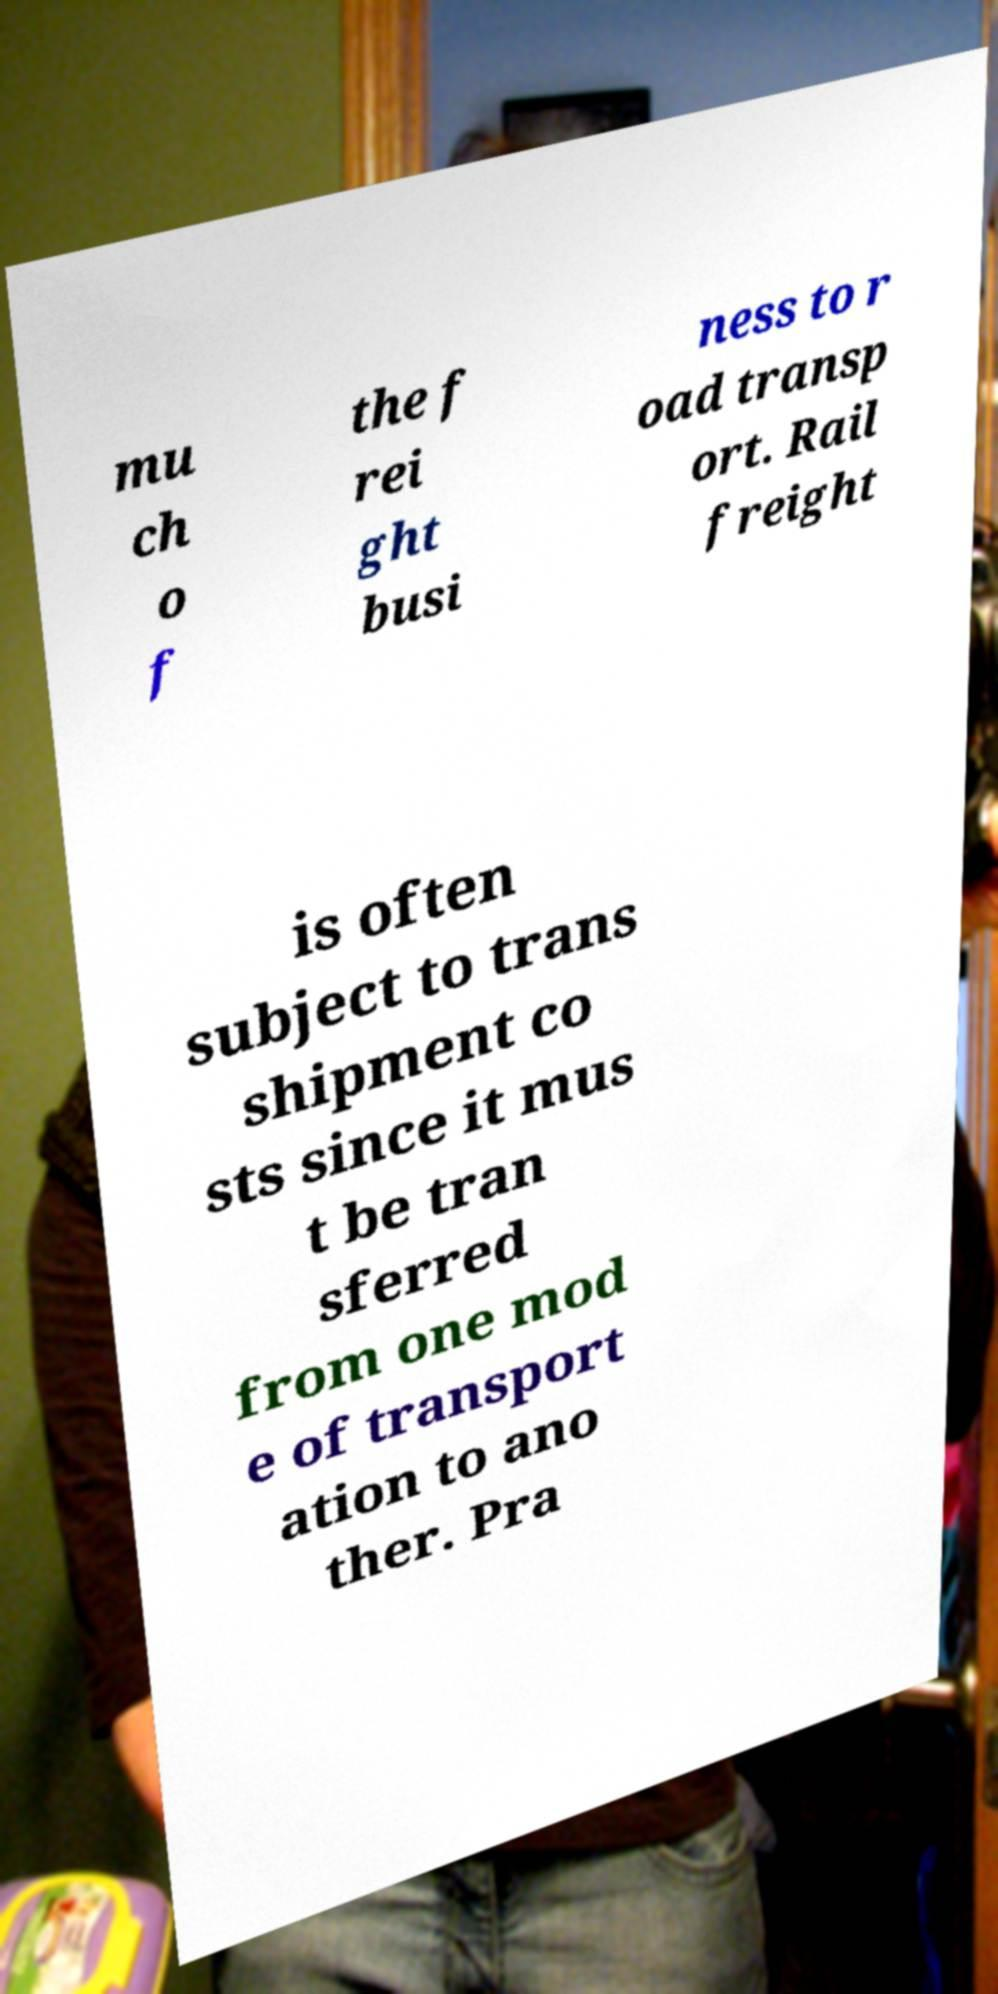I need the written content from this picture converted into text. Can you do that? mu ch o f the f rei ght busi ness to r oad transp ort. Rail freight is often subject to trans shipment co sts since it mus t be tran sferred from one mod e of transport ation to ano ther. Pra 